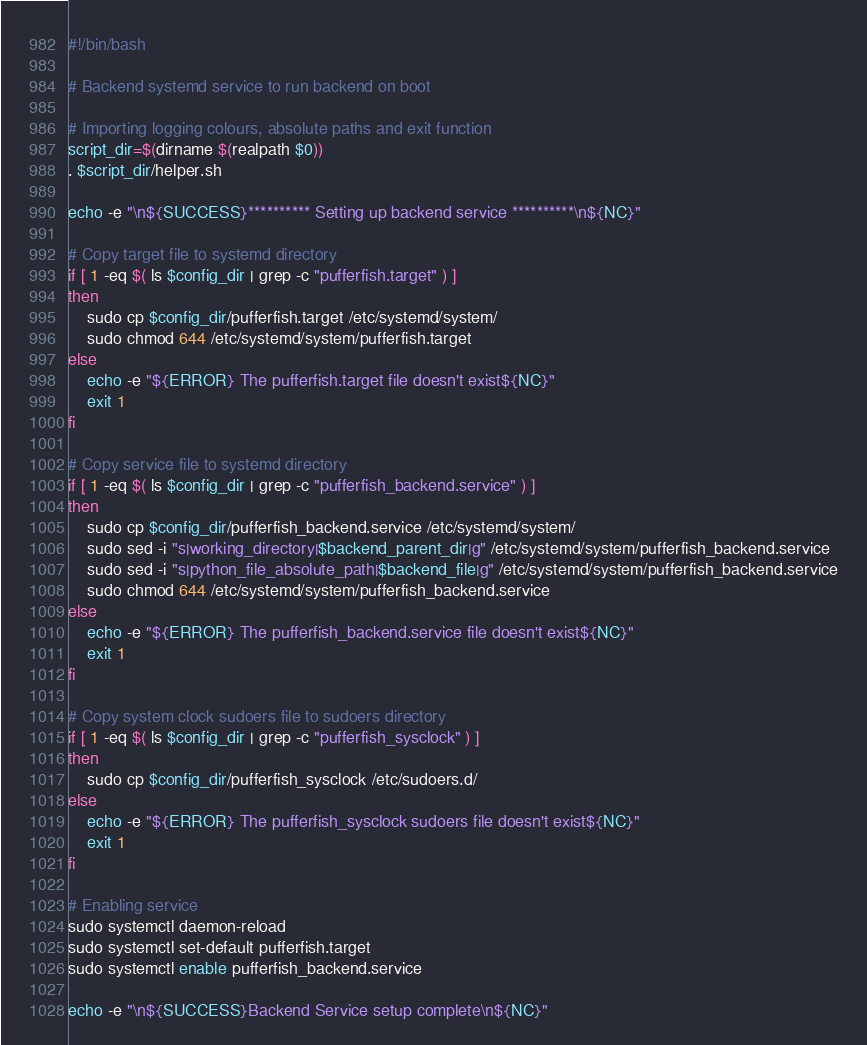Convert code to text. <code><loc_0><loc_0><loc_500><loc_500><_Bash_>#!/bin/bash

# Backend systemd service to run backend on boot

# Importing logging colours, absolute paths and exit function
script_dir=$(dirname $(realpath $0))
. $script_dir/helper.sh

echo -e "\n${SUCCESS}********** Setting up backend service **********\n${NC}"

# Copy target file to systemd directory
if [ 1 -eq $( ls $config_dir | grep -c "pufferfish.target" ) ]
then
    sudo cp $config_dir/pufferfish.target /etc/systemd/system/
    sudo chmod 644 /etc/systemd/system/pufferfish.target
else
    echo -e "${ERROR} The pufferfish.target file doesn't exist${NC}"
    exit 1
fi

# Copy service file to systemd directory
if [ 1 -eq $( ls $config_dir | grep -c "pufferfish_backend.service" ) ]
then
    sudo cp $config_dir/pufferfish_backend.service /etc/systemd/system/
    sudo sed -i "s|working_directory|$backend_parent_dir|g" /etc/systemd/system/pufferfish_backend.service
    sudo sed -i "s|python_file_absolute_path|$backend_file|g" /etc/systemd/system/pufferfish_backend.service
    sudo chmod 644 /etc/systemd/system/pufferfish_backend.service
else
    echo -e "${ERROR} The pufferfish_backend.service file doesn't exist${NC}"
    exit 1
fi

# Copy system clock sudoers file to sudoers directory
if [ 1 -eq $( ls $config_dir | grep -c "pufferfish_sysclock" ) ]
then
    sudo cp $config_dir/pufferfish_sysclock /etc/sudoers.d/
else
    echo -e "${ERROR} The pufferfish_sysclock sudoers file doesn't exist${NC}"
    exit 1
fi

# Enabling service
sudo systemctl daemon-reload
sudo systemctl set-default pufferfish.target
sudo systemctl enable pufferfish_backend.service

echo -e "\n${SUCCESS}Backend Service setup complete\n${NC}"
</code> 